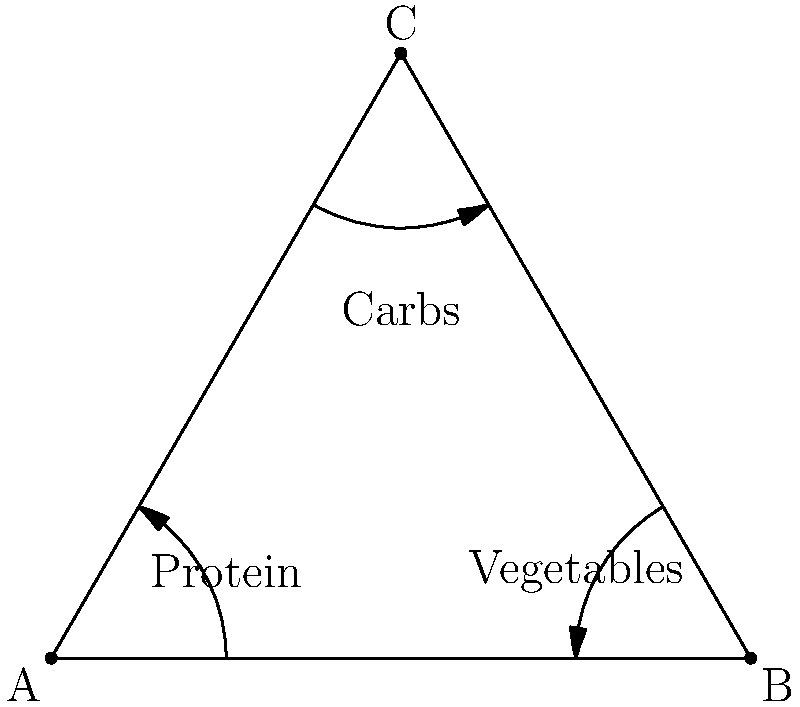In the optimal arrangement for portion control, what geometric shape should the plate be divided into, and how should the food groups be distributed? 1. The optimal arrangement for portion control follows the "Plate Method":
   - Divide the plate into three sections forming an equilateral triangle.

2. Food group distribution:
   - Protein: Occupies one-third of the plate (bottom left section).
   - Vegetables: Occupies one-third of the plate (bottom right section).
   - Carbohydrates: Occupies one-third of the plate (top section).

3. Benefits of this arrangement:
   - Ensures balanced proportions of each food group.
   - Visually easy to understand and implement.
   - Helps control portion sizes naturally.

4. Mathematical representation:
   - Each section of the equilateral triangle has an angle of 60°.
   - The area of each section is given by $A = \frac{\sqrt{3}}{4}a^2$, where $a$ is the side length of the triangle.

5. Nutritional rationale:
   - Protein: Essential for muscle maintenance and satiety.
   - Vegetables: Provide fiber, vitamins, and minerals with low calorie density.
   - Carbohydrates: Offer energy, but portion control is crucial for weight management.

This arrangement optimizes portion control by providing a visual guide that ensures a balanced meal while preventing overconsumption of any single food group.
Answer: Equilateral triangle; protein, vegetables, and carbs each occupy one-third. 